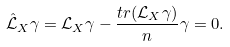<formula> <loc_0><loc_0><loc_500><loc_500>\hat { \mathcal { L } } _ { X } \gamma = { \mathcal { L } } _ { X } \gamma - \frac { t r ( \mathcal { L } _ { X } \gamma ) } { n } \gamma = 0 .</formula> 